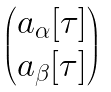Convert formula to latex. <formula><loc_0><loc_0><loc_500><loc_500>\begin{pmatrix} a _ { \alpha } [ \tau ] \\ a _ { \beta } [ \tau ] \\ \end{pmatrix}</formula> 